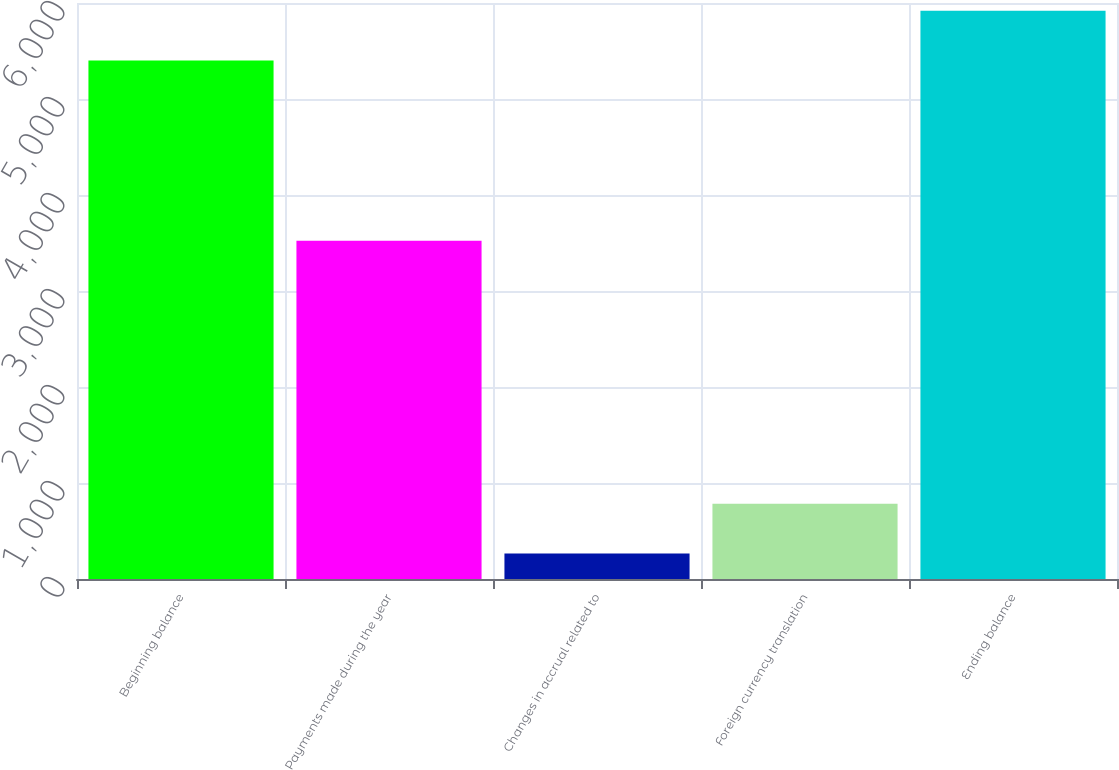Convert chart. <chart><loc_0><loc_0><loc_500><loc_500><bar_chart><fcel>Beginning balance<fcel>Payments made during the year<fcel>Changes in accrual related to<fcel>Foreign currency translation<fcel>Ending balance<nl><fcel>5401<fcel>3524<fcel>266<fcel>783.7<fcel>5918.7<nl></chart> 